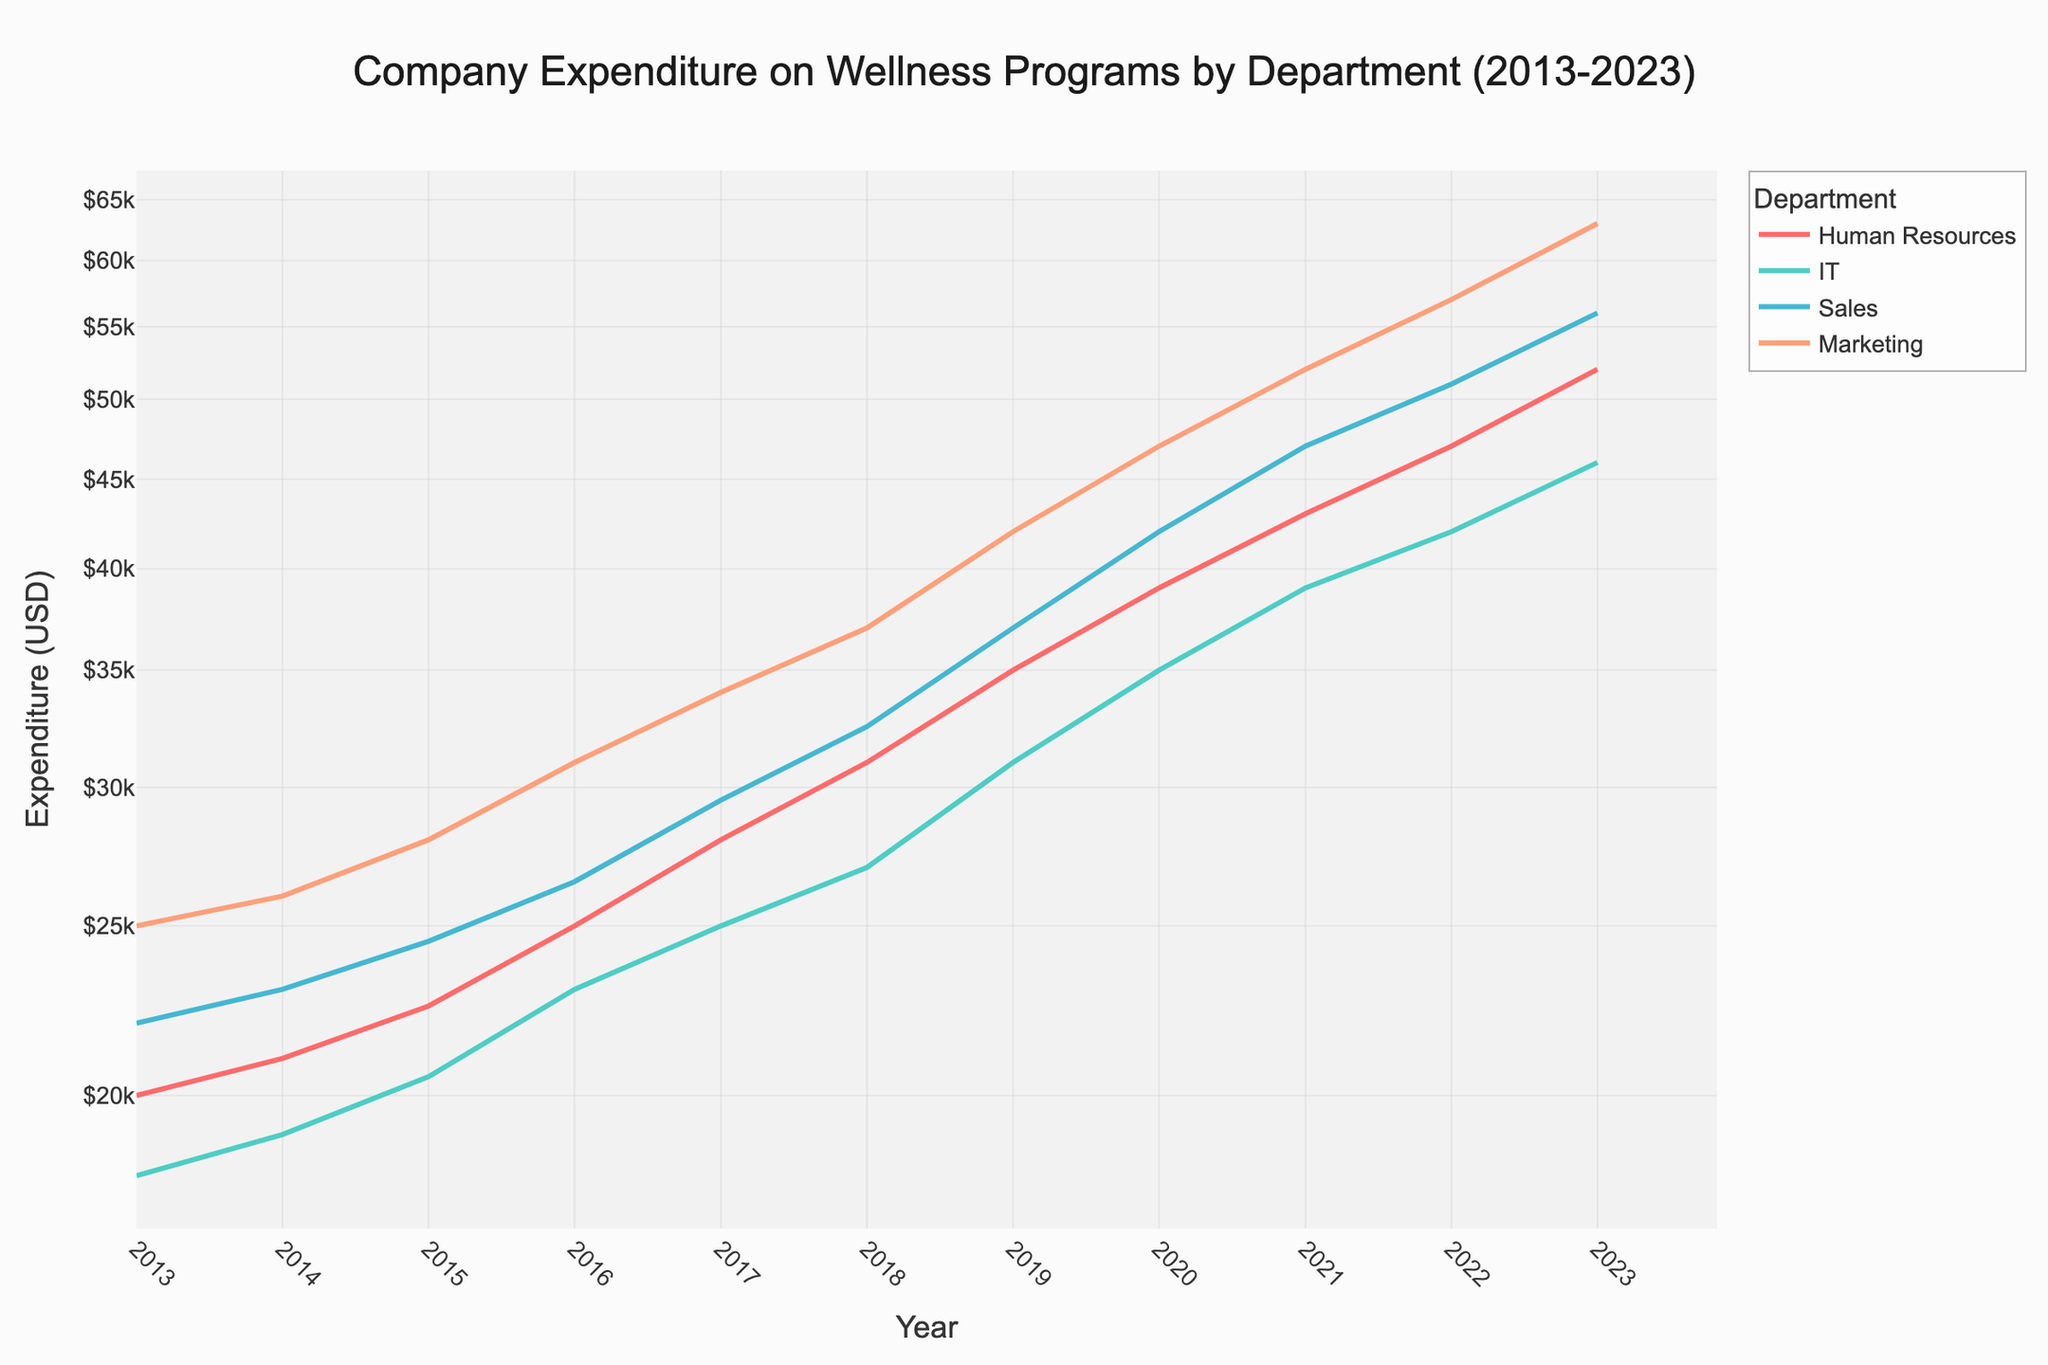What's the highest expenditure in 2023? To determine the highest expenditure in 2023, look for the department with the highest point on the y-axis for the year 2023. Marketing is the highest with $63,000.
Answer: $63,000 Which department had the lowest starting expenditure in 2013? Observe the lowest point on the y-axis for the starting year 2013. IT has the lowest starting expenditure of $18,000.
Answer: $18,000 What is the total expenditure for Human Resources across all the years shown? Sum the expenditure values for Human Resources across all years: $20,000 + $21,000 + $22,500 + $25,000 + $28,000 + $31,000 + $35,000 + $39,000 + $43,000 + $47,000 + $52,000 = $363,500.
Answer: $363,500 Which department showed the most significant increase in expenditure over the decade? Compare the increase in expenditure from 2013 to 2023 for each department. Marketing rose from $25,000 to $63,000, an increase of $38,000. This is the largest increase.
Answer: Marketing In which year did Sales and IT have the same expenditure? Scroll through the years and look for where the Sales and IT lines intersect. In 2023, both departments have identical expenditures of $46,000.
Answer: 2023 What is the average annual expenditure of the Marketing department from 2013 to 2023? Calculate the sum of Marketing expenditures over the 11 years and then divide by 11: ($25,000 + $26,000 + $28,000 + $31,000 + $34,000 + $37,000 + $42,000 + $47,000 + $52,000 + $57,000 + $63,000) / 11 = $39,000.
Answer: $39,000 By how much did the expenditure of IT increase from 2019 to 2023? Determine the expenditure of IT in 2019 and 2023 and then calculate the difference: $46,000 - $31,000 = $15,000.
Answer: $15,000 